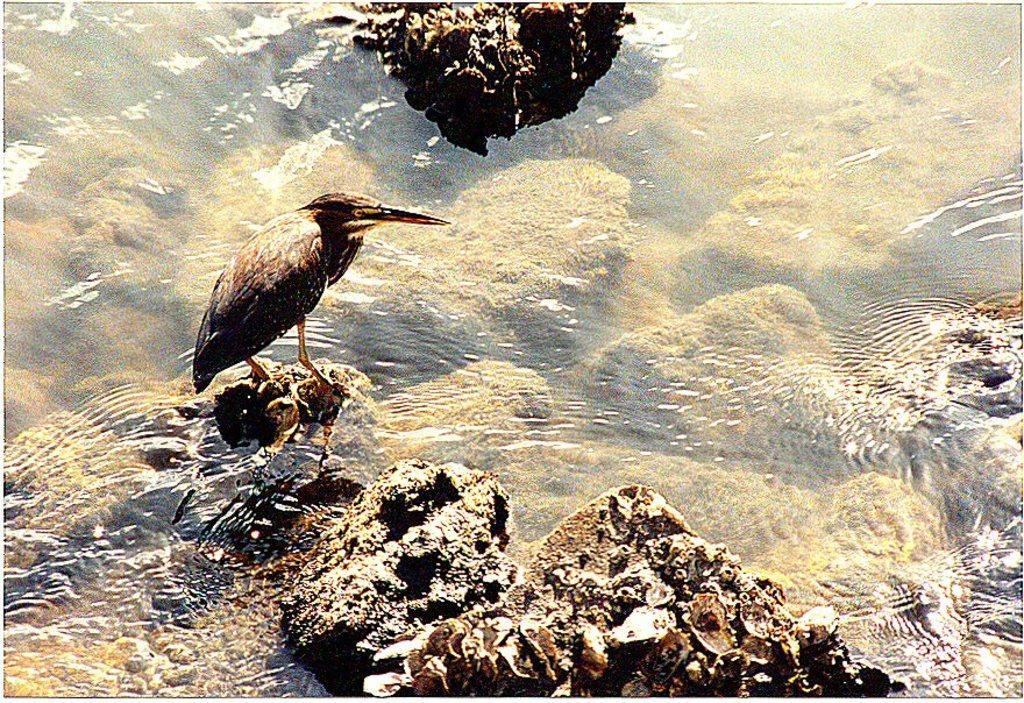Could you give a brief overview of what you see in this image? In this picture we can see a bird standing on a rock and beside this bird we can see water and rocks. 